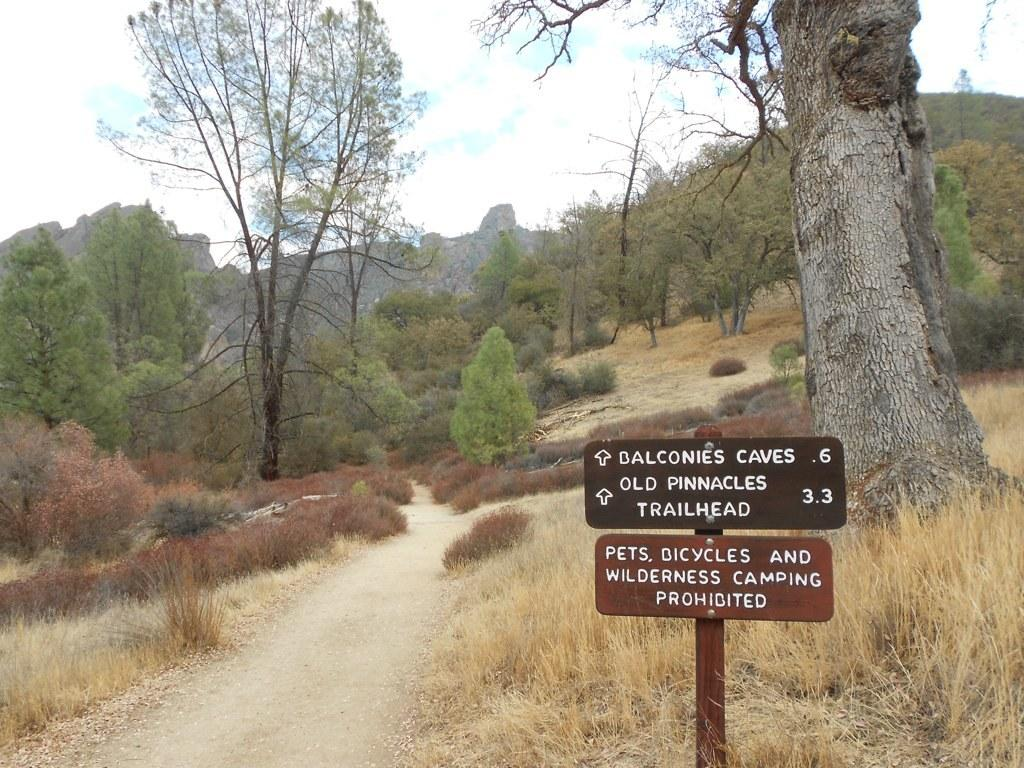How many signboards can be seen in the image? There are two signboards in the image. What colors are the signboards? The signboards are in black and brown color. What can be seen in the background of the image? Trees and dry grass are visible in the background. What is the color of the sky in the image? The sky is blue and white in color. How many balls are bouncing off the wall in the image? There are no balls or walls present in the image. 